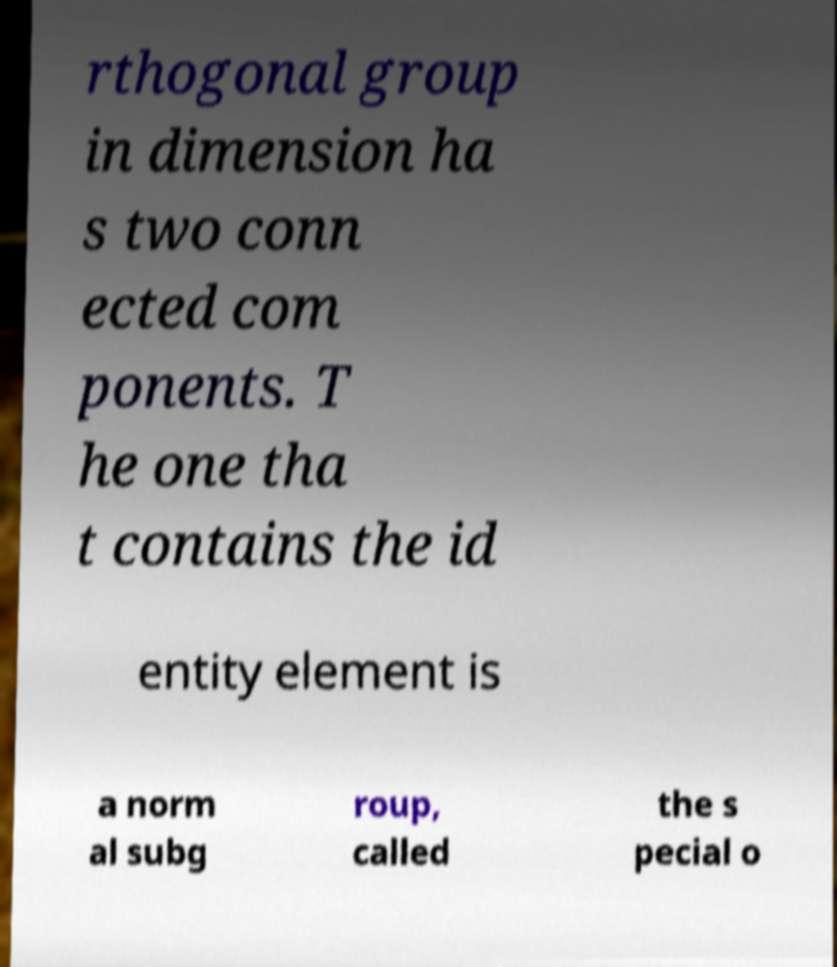Can you read and provide the text displayed in the image?This photo seems to have some interesting text. Can you extract and type it out for me? rthogonal group in dimension ha s two conn ected com ponents. T he one tha t contains the id entity element is a norm al subg roup, called the s pecial o 